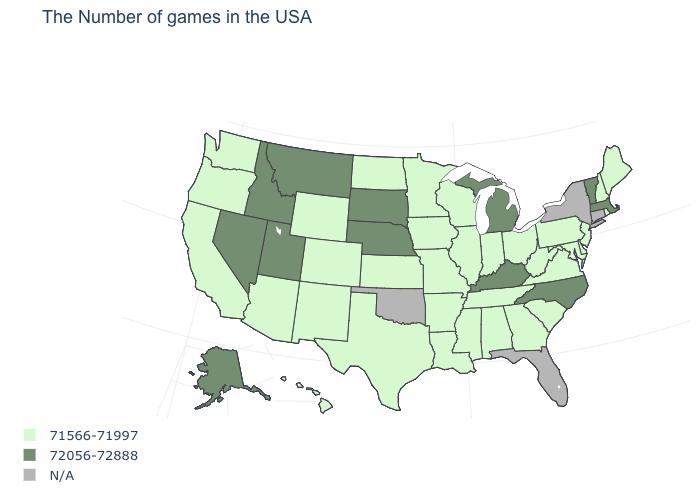How many symbols are there in the legend?
Be succinct. 3. Is the legend a continuous bar?
Keep it brief. No. What is the value of Ohio?
Give a very brief answer. 71566-71997. What is the value of Tennessee?
Keep it brief. 71566-71997. Which states have the highest value in the USA?
Write a very short answer. Massachusetts, Vermont, North Carolina, Michigan, Kentucky, Nebraska, South Dakota, Utah, Montana, Idaho, Nevada, Alaska. Which states have the lowest value in the USA?
Keep it brief. Maine, Rhode Island, New Hampshire, New Jersey, Delaware, Maryland, Pennsylvania, Virginia, South Carolina, West Virginia, Ohio, Georgia, Indiana, Alabama, Tennessee, Wisconsin, Illinois, Mississippi, Louisiana, Missouri, Arkansas, Minnesota, Iowa, Kansas, Texas, North Dakota, Wyoming, Colorado, New Mexico, Arizona, California, Washington, Oregon, Hawaii. How many symbols are there in the legend?
Concise answer only. 3. Which states have the lowest value in the USA?
Give a very brief answer. Maine, Rhode Island, New Hampshire, New Jersey, Delaware, Maryland, Pennsylvania, Virginia, South Carolina, West Virginia, Ohio, Georgia, Indiana, Alabama, Tennessee, Wisconsin, Illinois, Mississippi, Louisiana, Missouri, Arkansas, Minnesota, Iowa, Kansas, Texas, North Dakota, Wyoming, Colorado, New Mexico, Arizona, California, Washington, Oregon, Hawaii. What is the highest value in states that border Wisconsin?
Short answer required. 72056-72888. What is the value of Utah?
Short answer required. 72056-72888. Among the states that border Wyoming , which have the lowest value?
Keep it brief. Colorado. Does the map have missing data?
Write a very short answer. Yes. What is the value of Nebraska?
Give a very brief answer. 72056-72888. What is the value of Kansas?
Be succinct. 71566-71997. What is the value of West Virginia?
Answer briefly. 71566-71997. 